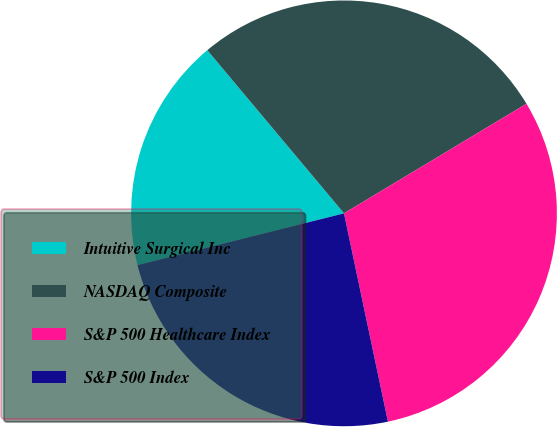<chart> <loc_0><loc_0><loc_500><loc_500><pie_chart><fcel>Intuitive Surgical Inc<fcel>NASDAQ Composite<fcel>S&P 500 Healthcare Index<fcel>S&P 500 Index<nl><fcel>17.81%<fcel>27.49%<fcel>30.3%<fcel>24.4%<nl></chart> 